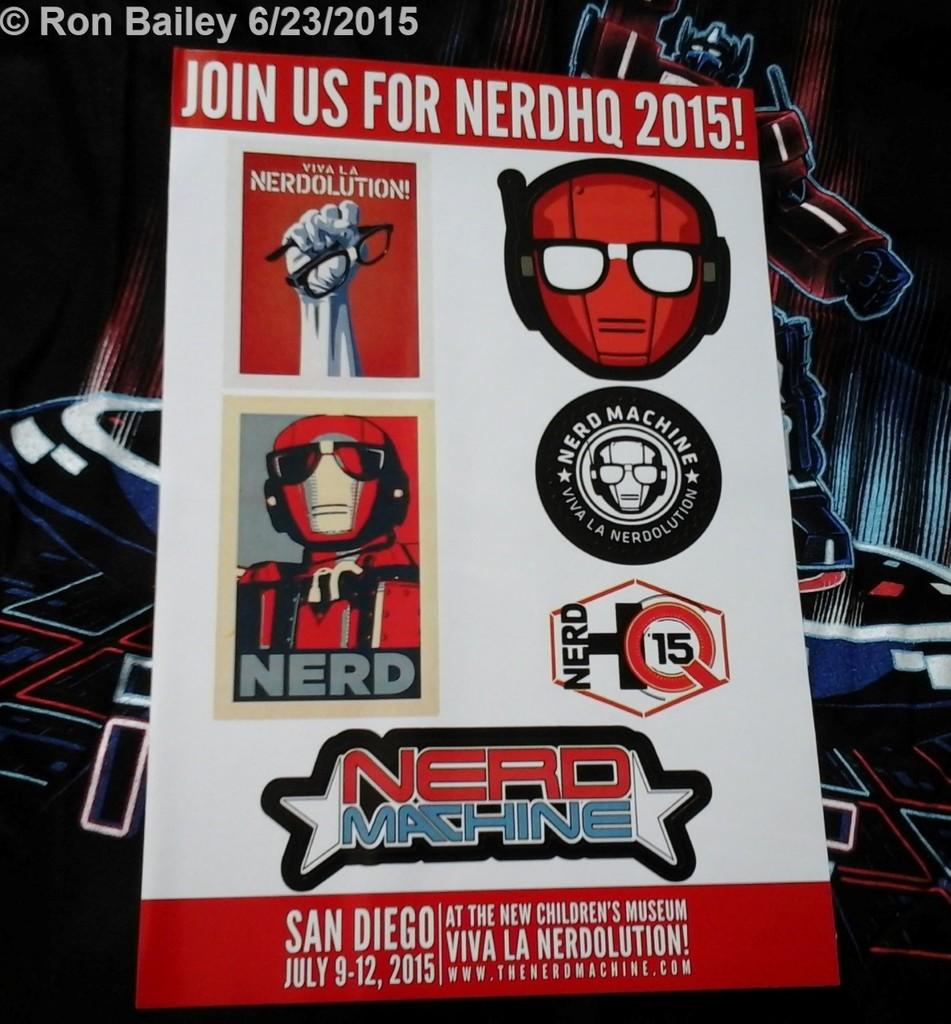What days in july did the nerdhq 2015 take place?
Ensure brevity in your answer.  9-12. 